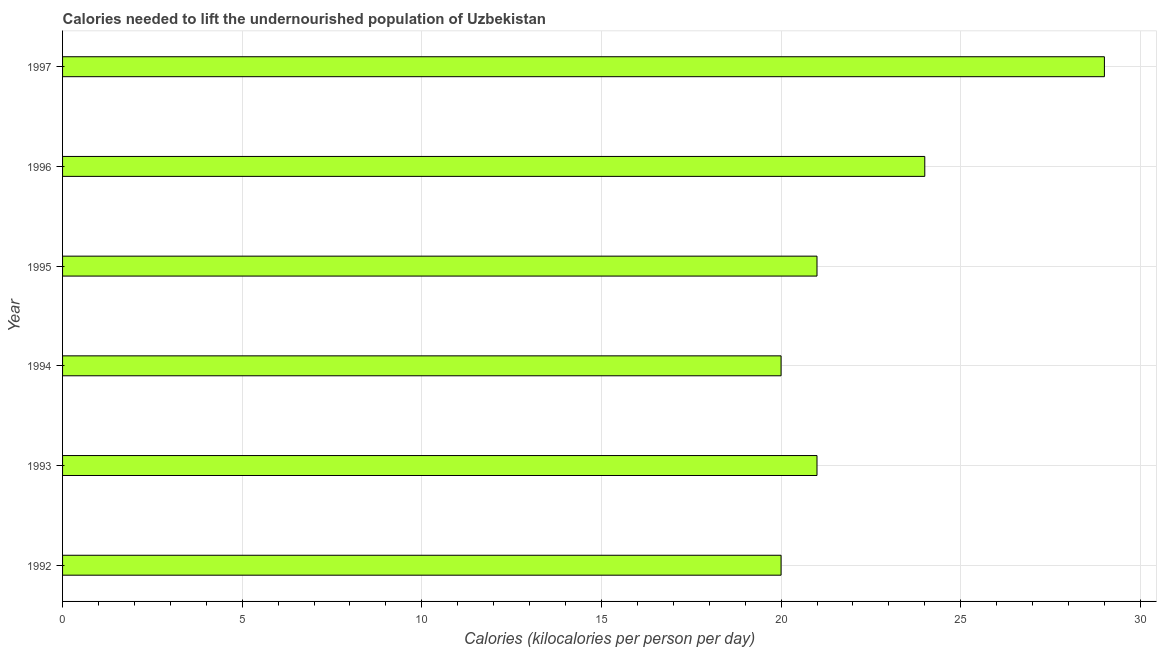Does the graph contain grids?
Your response must be concise. Yes. What is the title of the graph?
Make the answer very short. Calories needed to lift the undernourished population of Uzbekistan. What is the label or title of the X-axis?
Offer a very short reply. Calories (kilocalories per person per day). Across all years, what is the minimum depth of food deficit?
Ensure brevity in your answer.  20. In which year was the depth of food deficit maximum?
Your answer should be compact. 1997. In which year was the depth of food deficit minimum?
Your answer should be compact. 1992. What is the sum of the depth of food deficit?
Make the answer very short. 135. What is the difference between the depth of food deficit in 1992 and 1995?
Your response must be concise. -1. What is the average depth of food deficit per year?
Give a very brief answer. 22. What is the median depth of food deficit?
Offer a very short reply. 21. Do a majority of the years between 1992 and 1997 (inclusive) have depth of food deficit greater than 13 kilocalories?
Your answer should be compact. Yes. Is the depth of food deficit in 1994 less than that in 1997?
Your answer should be very brief. Yes. Is the difference between the depth of food deficit in 1992 and 1997 greater than the difference between any two years?
Offer a terse response. Yes. What is the difference between the highest and the second highest depth of food deficit?
Ensure brevity in your answer.  5. Is the sum of the depth of food deficit in 1992 and 1995 greater than the maximum depth of food deficit across all years?
Keep it short and to the point. Yes. What is the difference between the highest and the lowest depth of food deficit?
Offer a very short reply. 9. In how many years, is the depth of food deficit greater than the average depth of food deficit taken over all years?
Offer a very short reply. 2. Are all the bars in the graph horizontal?
Provide a succinct answer. Yes. What is the difference between two consecutive major ticks on the X-axis?
Your answer should be compact. 5. What is the Calories (kilocalories per person per day) in 1993?
Your response must be concise. 21. What is the Calories (kilocalories per person per day) of 1994?
Offer a very short reply. 20. What is the Calories (kilocalories per person per day) in 1996?
Make the answer very short. 24. What is the difference between the Calories (kilocalories per person per day) in 1992 and 1996?
Your answer should be very brief. -4. What is the difference between the Calories (kilocalories per person per day) in 1993 and 1995?
Make the answer very short. 0. What is the difference between the Calories (kilocalories per person per day) in 1993 and 1996?
Your answer should be very brief. -3. What is the difference between the Calories (kilocalories per person per day) in 1994 and 1996?
Provide a short and direct response. -4. What is the difference between the Calories (kilocalories per person per day) in 1996 and 1997?
Your answer should be very brief. -5. What is the ratio of the Calories (kilocalories per person per day) in 1992 to that in 1993?
Provide a short and direct response. 0.95. What is the ratio of the Calories (kilocalories per person per day) in 1992 to that in 1996?
Offer a terse response. 0.83. What is the ratio of the Calories (kilocalories per person per day) in 1992 to that in 1997?
Offer a terse response. 0.69. What is the ratio of the Calories (kilocalories per person per day) in 1993 to that in 1995?
Offer a terse response. 1. What is the ratio of the Calories (kilocalories per person per day) in 1993 to that in 1996?
Make the answer very short. 0.88. What is the ratio of the Calories (kilocalories per person per day) in 1993 to that in 1997?
Your answer should be very brief. 0.72. What is the ratio of the Calories (kilocalories per person per day) in 1994 to that in 1996?
Keep it short and to the point. 0.83. What is the ratio of the Calories (kilocalories per person per day) in 1994 to that in 1997?
Ensure brevity in your answer.  0.69. What is the ratio of the Calories (kilocalories per person per day) in 1995 to that in 1997?
Offer a terse response. 0.72. What is the ratio of the Calories (kilocalories per person per day) in 1996 to that in 1997?
Make the answer very short. 0.83. 